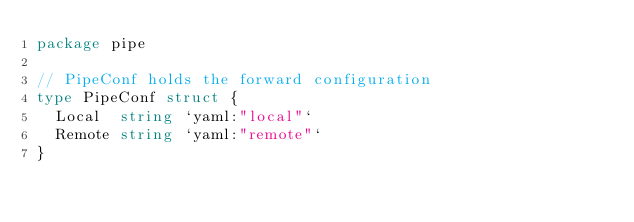Convert code to text. <code><loc_0><loc_0><loc_500><loc_500><_Go_>package pipe

// PipeConf holds the forward configuration
type PipeConf struct {
	Local  string `yaml:"local"`
	Remote string `yaml:"remote"`
}
</code> 